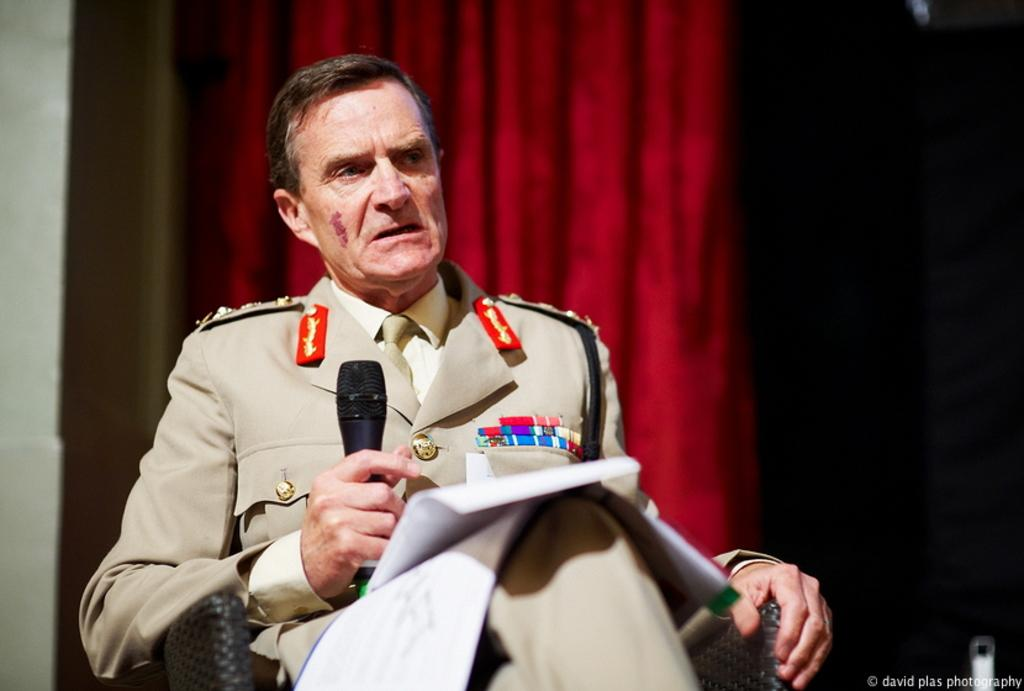Who is the main subject in the image? There is a man in the image. What is the man doing in the image? The man is sitting on a chair and talking. What object is the man holding in the image? The man is holding a microphone. What can be seen in the background of the image? There is a curtain in the background of the image. Where is the text located in the image? The text is in the bottom right corner of the image. What type of veil is draped over the man's head in the image? There is no veil present in the image; the man is not wearing any head covering. What idea does the text in the bottom right corner of the image convey? The text in the image cannot be read or interpreted in the conversation, as it is not mentioned in the provided facts. 